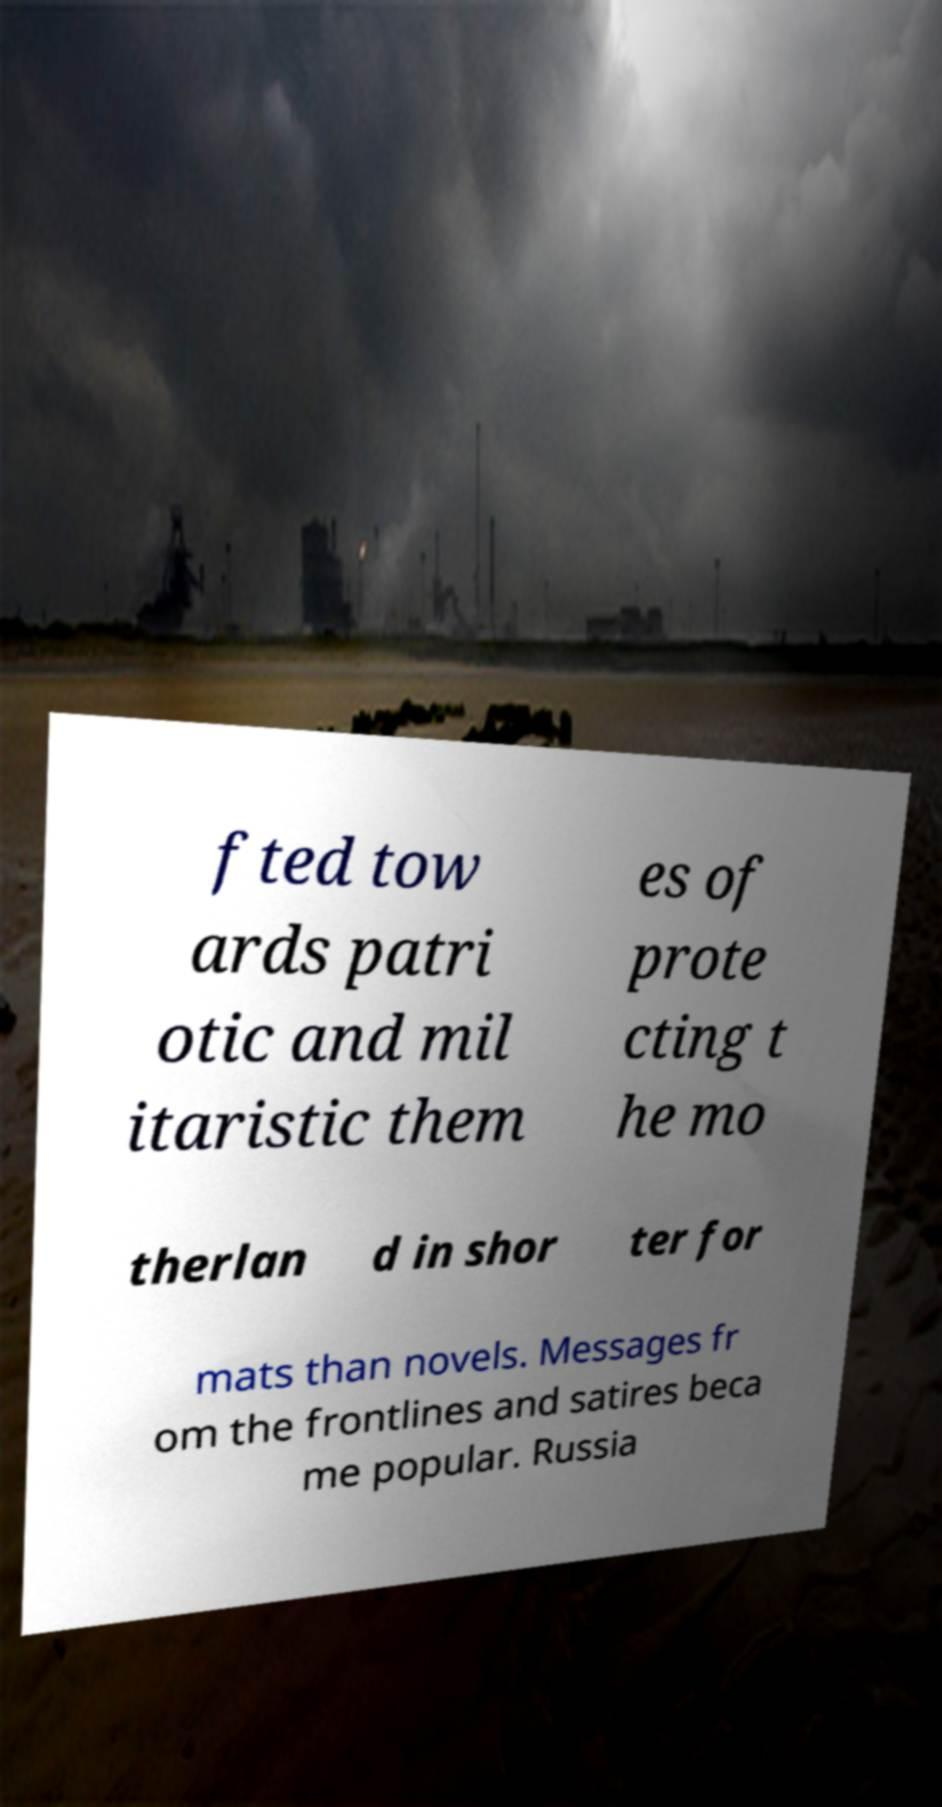Please read and relay the text visible in this image. What does it say? fted tow ards patri otic and mil itaristic them es of prote cting t he mo therlan d in shor ter for mats than novels. Messages fr om the frontlines and satires beca me popular. Russia 